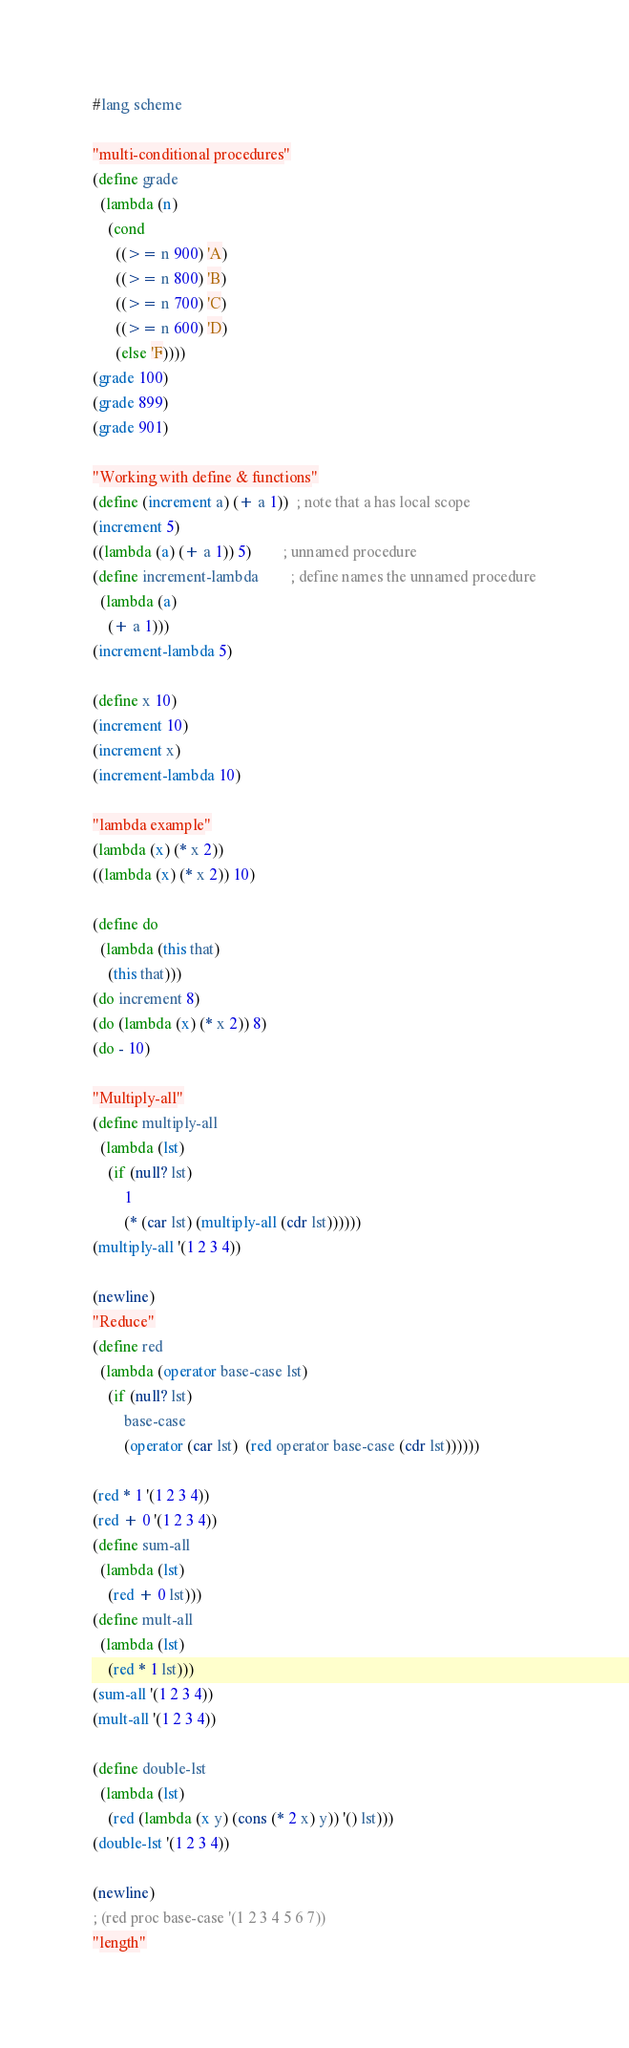<code> <loc_0><loc_0><loc_500><loc_500><_Scheme_>#lang scheme

"multi-conditional procedures"
(define grade
  (lambda (n)
    (cond
      ((>= n 900) 'A)
      ((>= n 800) 'B)
      ((>= n 700) 'C)
      ((>= n 600) 'D)
      (else 'F))))
(grade 100)
(grade 899)
(grade 901)

"Working with define & functions"
(define (increment a) (+ a 1))  ; note that a has local scope
(increment 5)
((lambda (a) (+ a 1)) 5)        ; unnamed procedure
(define increment-lambda        ; define names the unnamed procedure
  (lambda (a)
    (+ a 1)))
(increment-lambda 5)

(define x 10)
(increment 10)
(increment x)
(increment-lambda 10)

"lambda example"
(lambda (x) (* x 2))
((lambda (x) (* x 2)) 10)

(define do
  (lambda (this that)
    (this that)))
(do increment 8)
(do (lambda (x) (* x 2)) 8)
(do - 10)

"Multiply-all"
(define multiply-all
  (lambda (lst)
    (if (null? lst)
        1
        (* (car lst) (multiply-all (cdr lst))))))
(multiply-all '(1 2 3 4))

(newline)
"Reduce"
(define red
  (lambda (operator base-case lst)
    (if (null? lst)
        base-case
        (operator (car lst)  (red operator base-case (cdr lst))))))

(red * 1 '(1 2 3 4))
(red + 0 '(1 2 3 4))
(define sum-all
  (lambda (lst)
    (red + 0 lst)))
(define mult-all
  (lambda (lst)
    (red * 1 lst)))
(sum-all '(1 2 3 4))
(mult-all '(1 2 3 4))

(define double-lst
  (lambda (lst)
    (red (lambda (x y) (cons (* 2 x) y)) '() lst)))
(double-lst '(1 2 3 4))

(newline)
; (red proc base-case '(1 2 3 4 5 6 7))
"length"</code> 